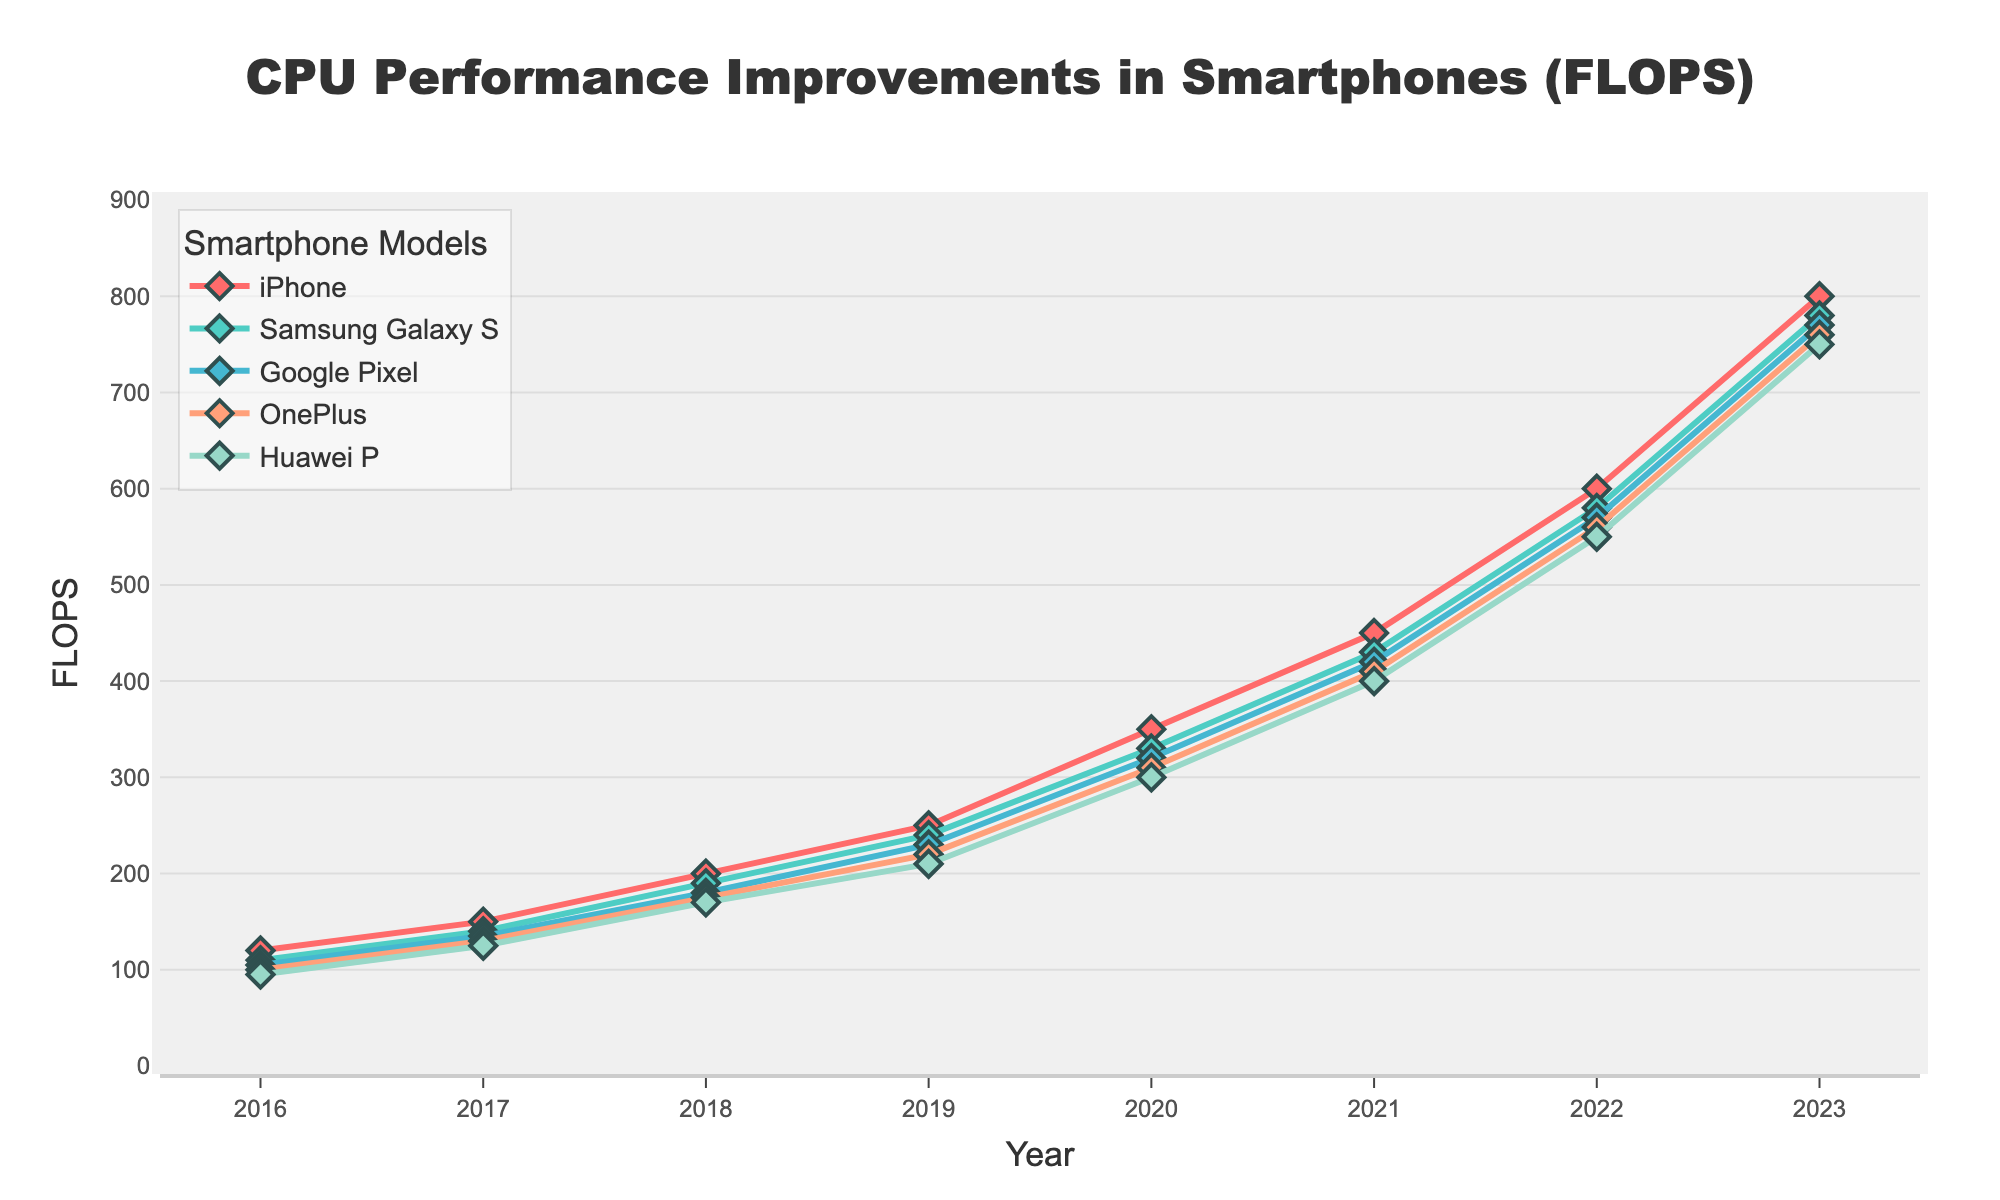What year did the iPhone surpass 300 FLOPS? In 2020, the iPhone's performance was above 300 FLOPS, reaching exactly 350 FLOPS according to the figure.
Answer: 2020 Which smartphone model had the highest CPU performance in 2022? In 2022, the iPhone had the highest CPU performance, reaching 600 FLOPS.
Answer: iPhone What is the increase in CPU performance of the Samsung Galaxy S from 2018 to 2023? In 2018, the Samsung Galaxy S had 190 FLOPS and in 2023 it had 780 FLOPS. The increase is 780 - 190 = 590 FLOPS.
Answer: 590 FLOPS Compare the CPU performance of OnePlus and Google Pixel in 2019. Which was higher and by how much? In 2019, Google Pixel had 230 FLOPS while OnePlus had 220 FLOPS. Google Pixel had a higher performance by 230 - 220 = 10 FLOPS.
Answer: Google Pixel, by 10 FLOPS What is the average CPU performance of Huawei P over the period from 2016 to 2023? First sum the performance values for Huawei P from 2016 to 2023: 95 + 125 + 170 + 210 + 300 + 400 + 550 + 750 = 2600. There are 8 years, so the average is 2600/8 = 325 FLOPS.
Answer: 325 FLOPS Which year saw the biggest year-over-year improvement in CPU performance for the iPhone? From the data, the differences year by year for iPhone are: (150-120)=30, (200-150)=50, (250-200)=50, (350-250)=100, (450-350)=100, (600-450)=150, (800-600)=200. The largest increase occurred between 2022 and 2023, with an increase of 200 FLOPS.
Answer: 2023 What was the trend in CPU performance for all smartphone models between 2016 and 2023? The visual trend shows a consistent increase in CPU performance across all smartphone models from 2016 to 2023. Each model shows a sharp upward trajectory in FLOPS values.
Answer: Increasing trend In which year did the Google Pixel cross the 500 FLOPS mark? From the chart, in 2022, the Google Pixel's CPU performance reached 570 FLOPS, which is the first time it crossed the 500 FLOPS mark.
Answer: 2022 What color represents the OnePlus model in the figure? The OnePlus model is represented by the color orange in the figure.
Answer: Orange 